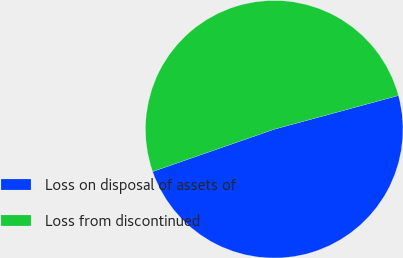Convert chart. <chart><loc_0><loc_0><loc_500><loc_500><pie_chart><fcel>Loss on disposal of assets of<fcel>Loss from discontinued<nl><fcel>48.89%<fcel>51.11%<nl></chart> 